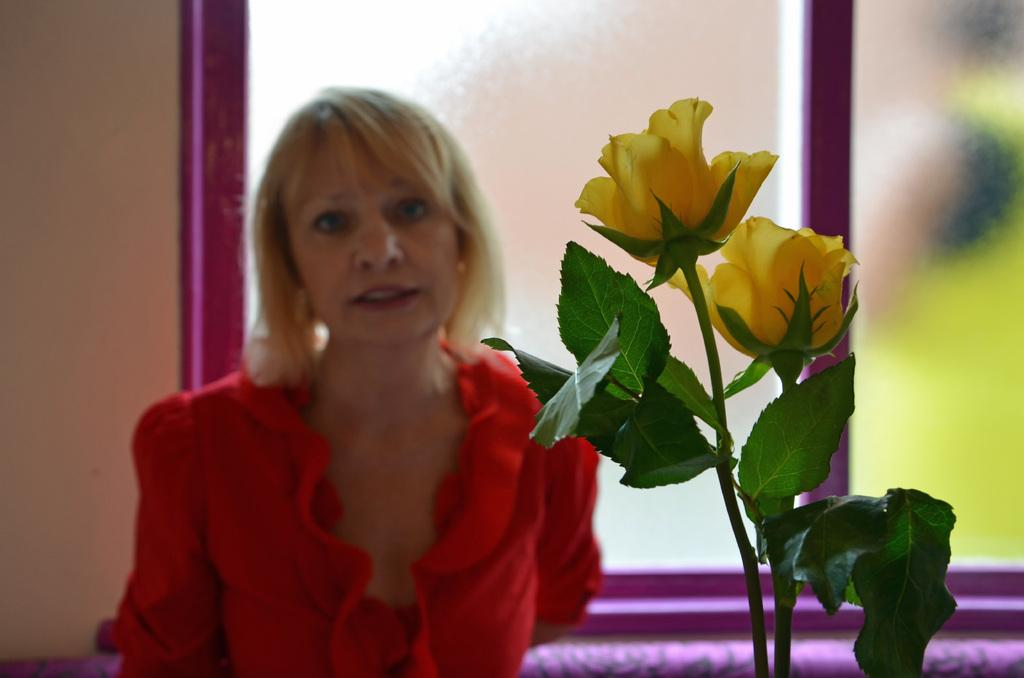Who is the main subject in the image? There is a woman in the image. What is the woman wearing? The woman is wearing a red dress. What type of plants can be seen in the image? There are yellow flowers and green leaves in the image. How would you describe the overall quality of the image? The image is slightly blurry in the background. What type of poison is the woman using in the image? There is no indication in the image that the woman is using any poison, and therefore no such activity can be observed. 